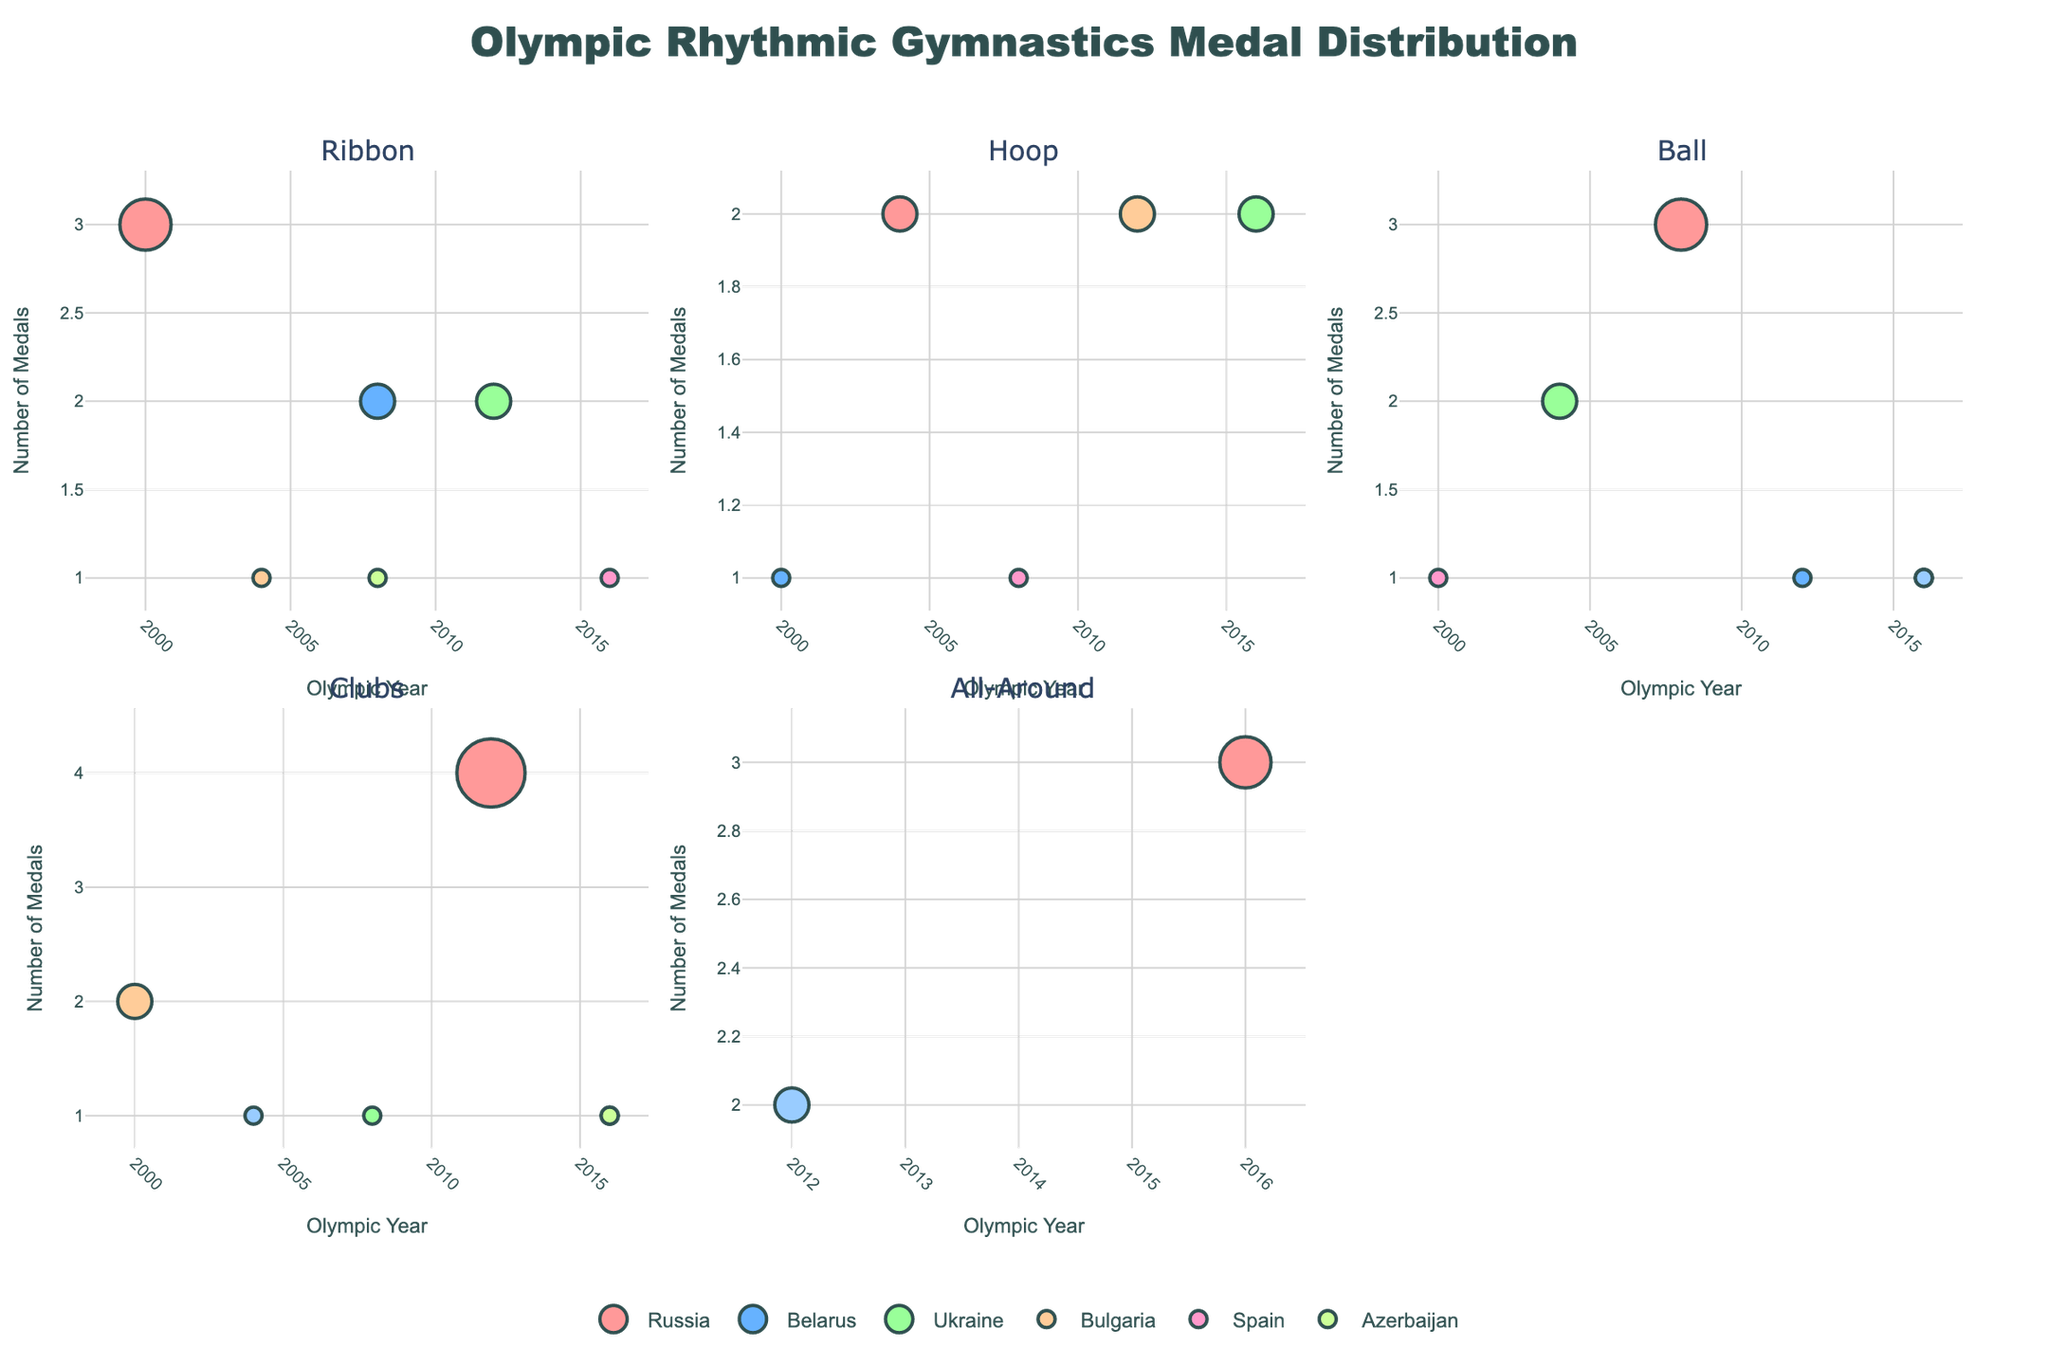Which country has the highest total number of medals? The entire dataset is used to sum the total number of medals for each country. Russia has a total of 15 medals distributed across various apparatus and Olympic years.
Answer: Russia Which apparatus has the most medals awarded to Belarus? By examining all the bubbles for Belarus, we see that the Ribbon apparatus in 2008 has the most medals awarded with 2 medals.
Answer: Ribbon in 2008 How many medals did Ukraine win in the 2004 Olympics? Looking at the subplot corresponding to Ukraine, we count the medals in 2004 which only appear in the Ball apparatus, totaling 2 medals.
Answer: 2 medals Which countries won medals in the Clubs apparatus during the 2016 Olympics? By examining the Clubs subplot closely, we see that Russia, Belarus, and Azerbaijan have bubbles indicating they won medals in this apparatus in 2016.
Answer: Russia, Belarus, and Azerbaijan Compare the number of medals Russia won in the Hoops apparatus during 2004 and 2016. The subplot for Hoops shows that Russia won 2 medals in 2004 and none in 2016 (no bubble for Russia in 2016).
Answer: Russia won 2 medals in 2004 and none in 2016 Which country won medals in both Ball and Ribbon apparatus but not in Hoop? By checking each subplot, we see that Spain has bubbles in Ball and Ribbon apparatus but does not appear in the Hoop subplot.
Answer: Spain Is the distribution of medals even across the different Olympic Games for Italy? Reviewing all the bubbles for Italy, we notice that Italy has medals mostly in 2004, 2012, and 2016, indicating an uneven distribution of medals across the different Olympic Games.
Answer: Uneven distribution How many total medals did Spain win across all Olympics? Summing up all of Spain's medals from the Ball (1), Hoop (1), and Ribbon (1) apparatus, Spain won a total of 3 medals.
Answer: 3 medals Between Belarus and Bulgaria, which country has a higher total number of medals in Ribbon and Ball apparatus combined? By checking the respective bubbles:
   - Belarus: Ribbon (2 in 2008), Ball (1 in 2012) = 3 total
   - Bulgaria: Ribbon (1 in 2004), Ball (1 in 2016) = 2 total
 Belarus has more total medals in these apparatus.
Answer: Belarus 